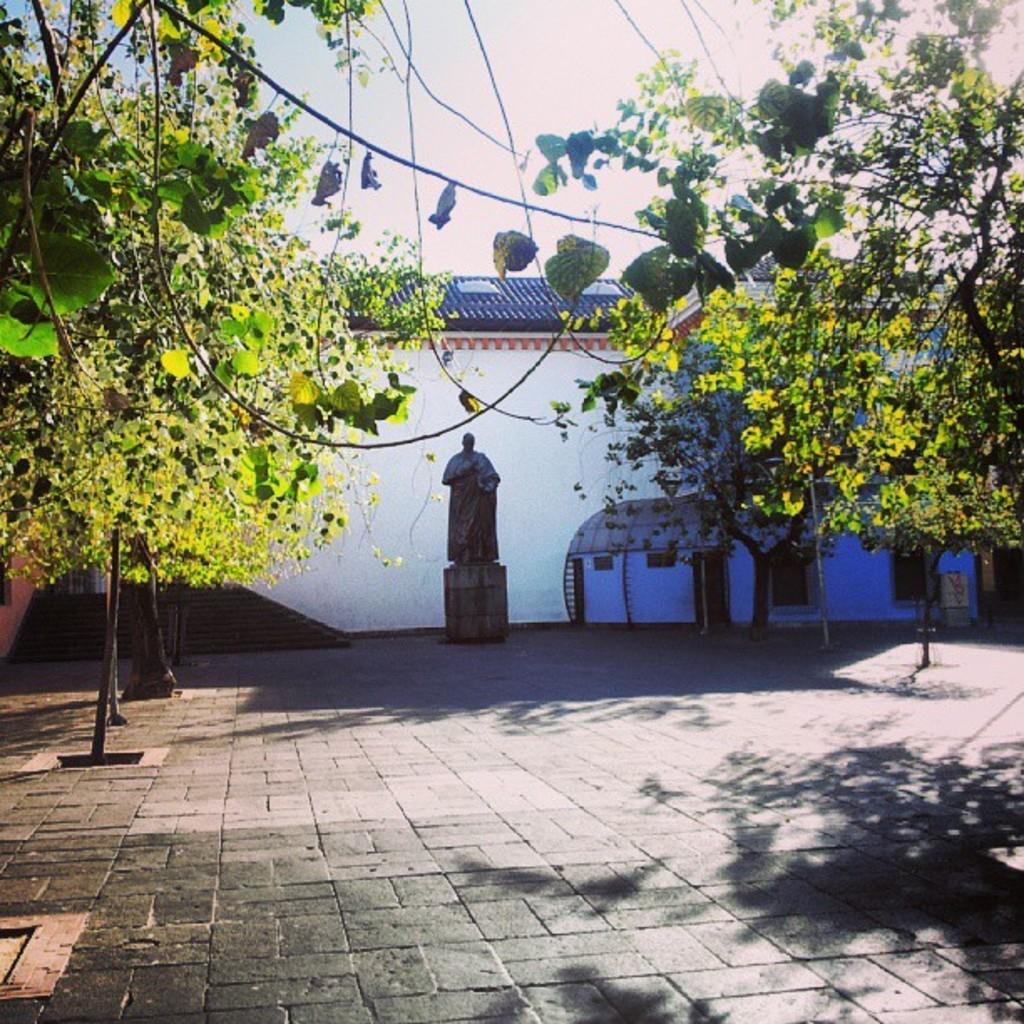Please provide a concise description of this image. In the image there are trees on either side of the floor with building in the back with statue in the middle and above its sky. 